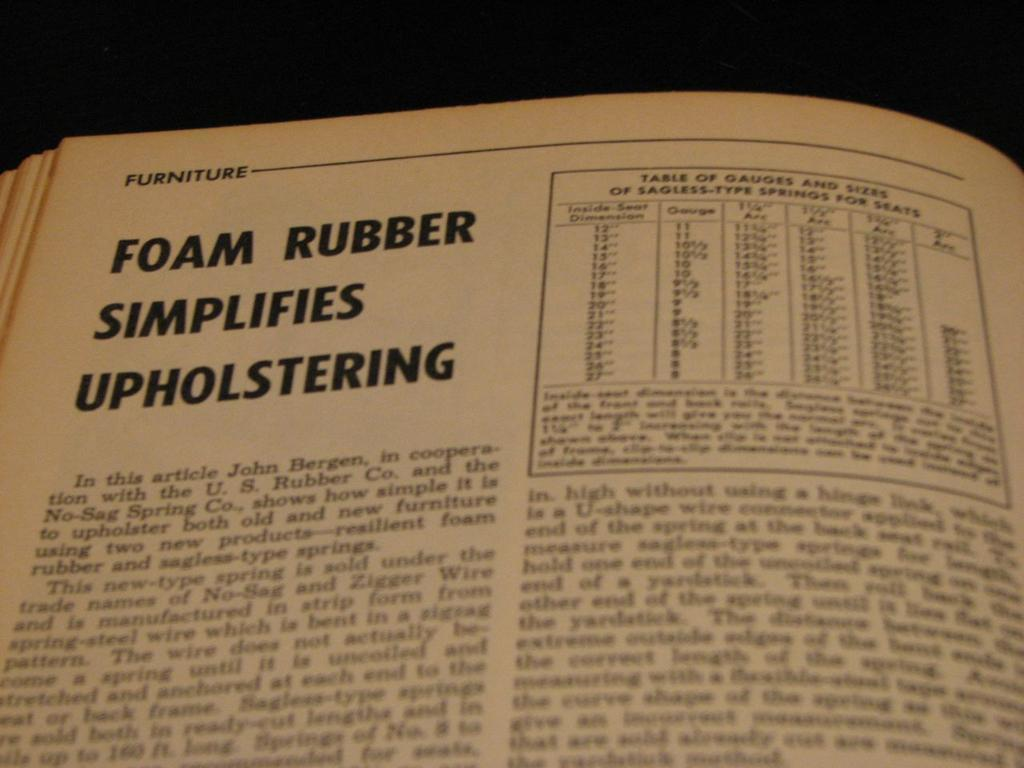<image>
Offer a succinct explanation of the picture presented. An article from a textbook regarding foam rubber simplifies upholstering. 